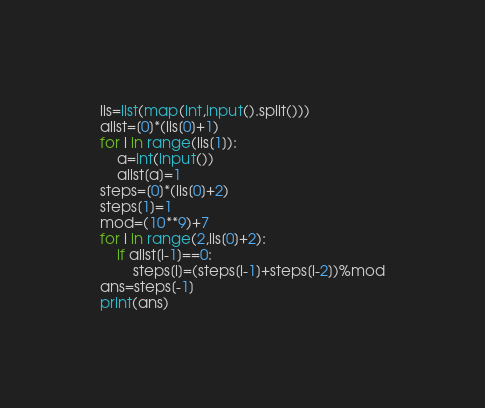Convert code to text. <code><loc_0><loc_0><loc_500><loc_500><_Python_>lis=list(map(int,input().split()))
alist=[0]*(lis[0]+1)
for i in range(lis[1]):
    a=int(input())
    alist[a]=1
steps=[0]*(lis[0]+2)
steps[1]=1
mod=(10**9)+7
for i in range(2,lis[0]+2):
    if alist[i-1]==0:
        steps[i]=(steps[i-1]+steps[i-2])%mod
ans=steps[-1]
print(ans)
</code> 